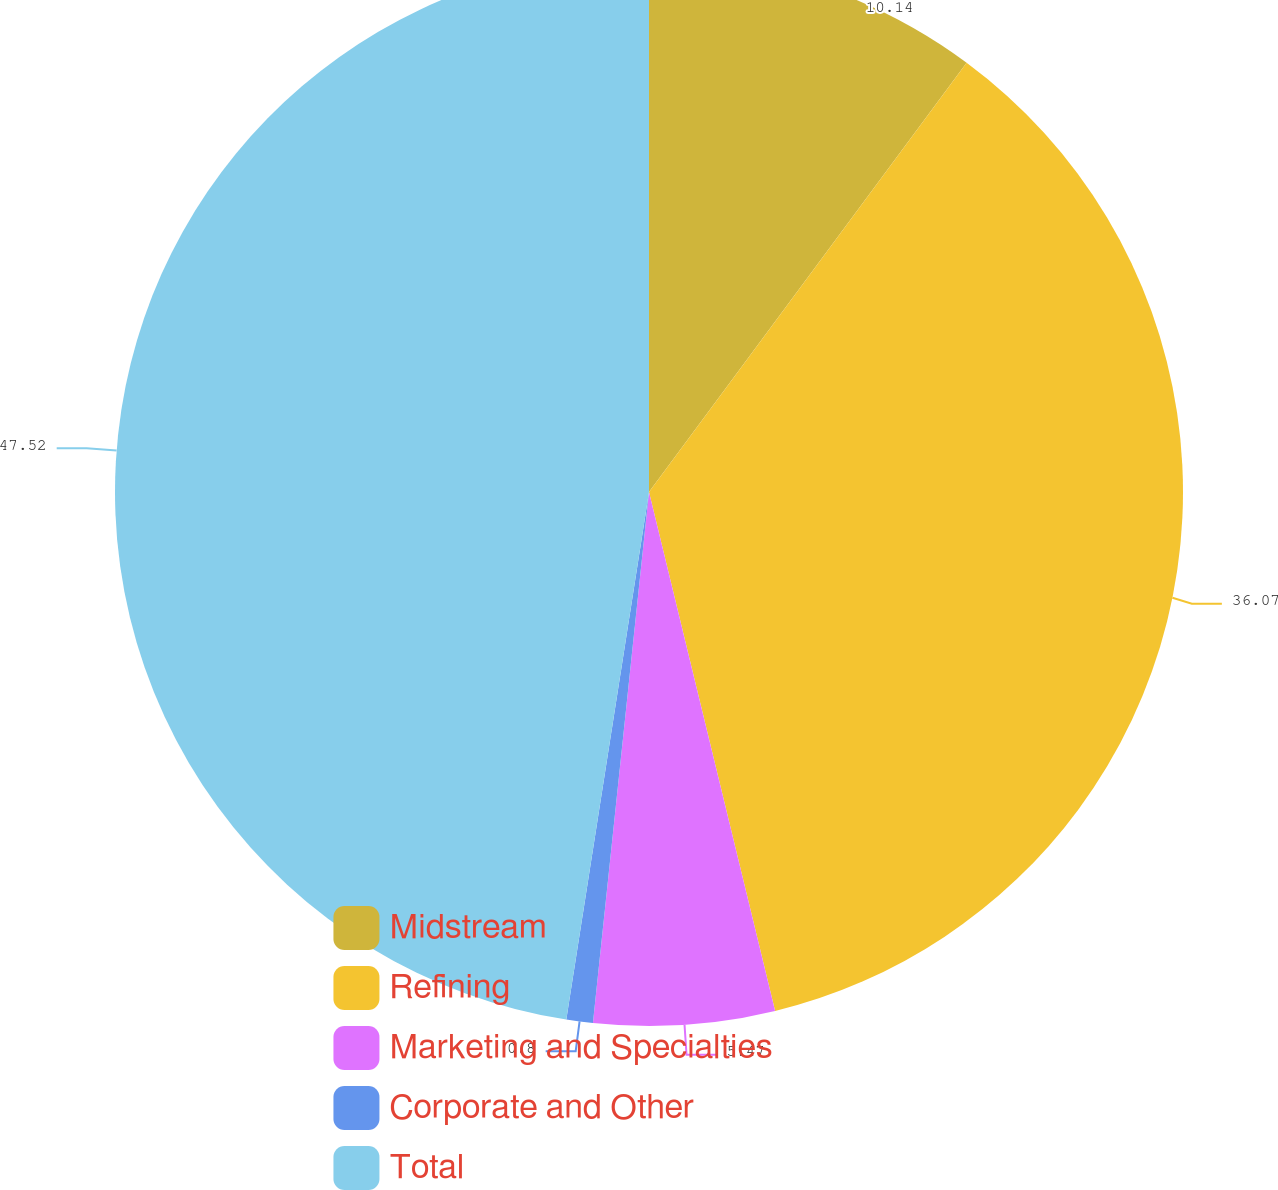Convert chart to OTSL. <chart><loc_0><loc_0><loc_500><loc_500><pie_chart><fcel>Midstream<fcel>Refining<fcel>Marketing and Specialties<fcel>Corporate and Other<fcel>Total<nl><fcel>10.14%<fcel>36.07%<fcel>5.47%<fcel>0.8%<fcel>47.53%<nl></chart> 